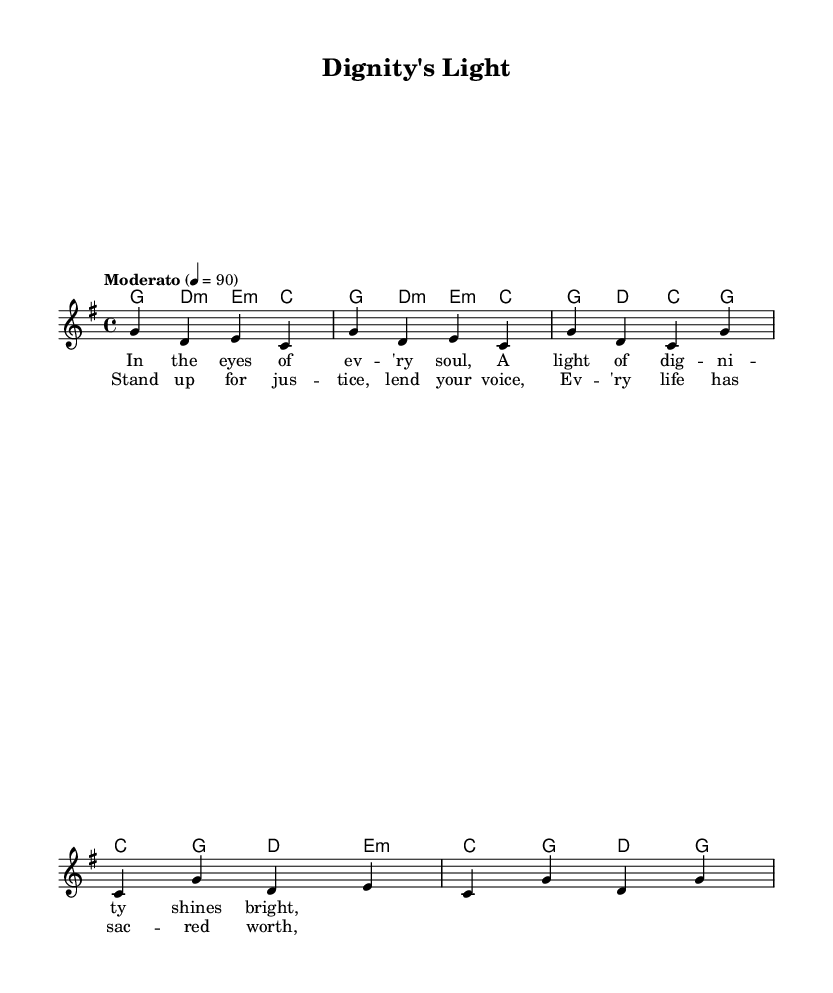What is the key signature of this music? The key signature in the music indicates that it is in G major, which has one sharp (F#). This can be identified in the provided data under the global section where it states: "\key g \major".
Answer: G major What is the time signature of this music? The time signature is found in the global section of the music data. It is stated as "\time 4/4", which means there are four beats in a measure, and each quarter note receives one beat.
Answer: 4/4 What is the tempo marking for this piece? The tempo marking in the music indicates the speed at which the piece should be played, specified as "Moderato" at a quarter note equals 90 beats per minute. This is given in the global section as: "\tempo 'Moderato' 4 = 90".
Answer: Moderato How many measures are presented in the melody? To determine the number of measures, we count the sections of music notated with vertical lines, indicating the end of each measure. The melody section lists two measures from the intro and two from the verse, totaling four measures.
Answer: 4 What is the first line of the lyrics? The first line of the lyrics is written in the verse section of the music data: "In the eyes of ev -- 'ry soul,". This is confirmed as the opening phrase of the lyrics related to the melody.
Answer: In the eyes of ev -- 'ry soul What emotion or theme does the chorus convey? The chorus, particularly with the lines "Stand up for jus -- tice, lend your voice," suggests a theme of social justice and advocacy for human dignity. This can be inferred as the lyrics connect deeply with the subject matter of dignity for every life.
Answer: Social justice How does the harmony support the melody? The harmony is structured in a chord mode that corresponds with the melody notes being sung. For example, the first section starts with a G major chord which complements the melody notes G, D, and C in the introduction. This interplay between harmony and melody creates a rich musical texture.
Answer: Chordal support 